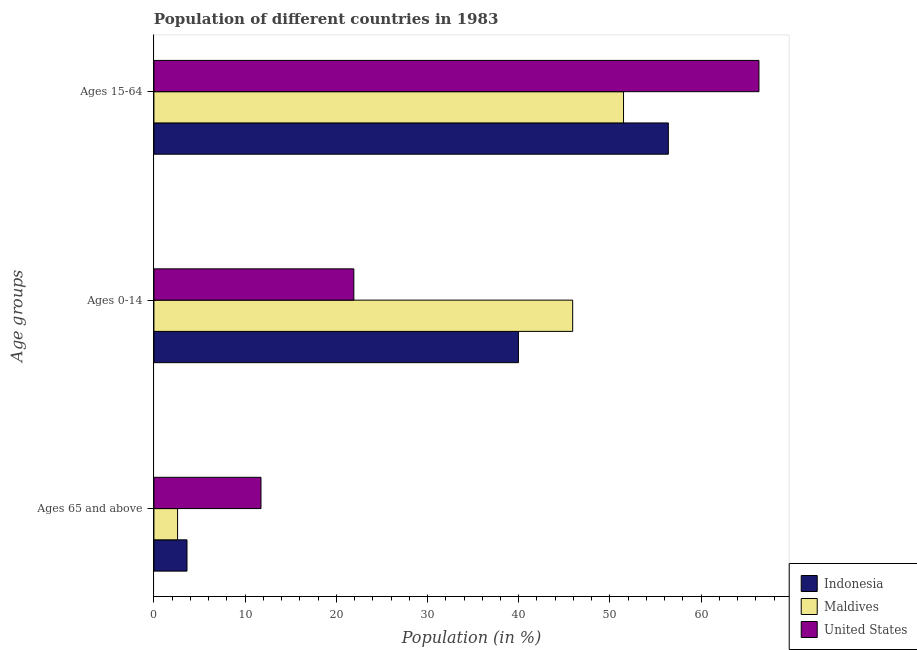How many groups of bars are there?
Offer a terse response. 3. Are the number of bars on each tick of the Y-axis equal?
Offer a terse response. Yes. How many bars are there on the 1st tick from the top?
Ensure brevity in your answer.  3. How many bars are there on the 1st tick from the bottom?
Make the answer very short. 3. What is the label of the 3rd group of bars from the top?
Offer a terse response. Ages 65 and above. What is the percentage of population within the age-group 0-14 in Maldives?
Offer a terse response. 45.92. Across all countries, what is the maximum percentage of population within the age-group 0-14?
Provide a succinct answer. 45.92. Across all countries, what is the minimum percentage of population within the age-group 0-14?
Keep it short and to the point. 21.92. In which country was the percentage of population within the age-group 15-64 minimum?
Make the answer very short. Maldives. What is the total percentage of population within the age-group 15-64 in the graph?
Offer a very short reply. 174.24. What is the difference between the percentage of population within the age-group 0-14 in United States and that in Maldives?
Offer a terse response. -23.99. What is the difference between the percentage of population within the age-group of 65 and above in Maldives and the percentage of population within the age-group 0-14 in Indonesia?
Ensure brevity in your answer.  -37.37. What is the average percentage of population within the age-group 15-64 per country?
Your answer should be compact. 58.08. What is the difference between the percentage of population within the age-group 0-14 and percentage of population within the age-group 15-64 in United States?
Keep it short and to the point. -44.42. In how many countries, is the percentage of population within the age-group of 65 and above greater than 48 %?
Offer a terse response. 0. What is the ratio of the percentage of population within the age-group 0-14 in Maldives to that in United States?
Your answer should be very brief. 2.09. Is the percentage of population within the age-group of 65 and above in Maldives less than that in Indonesia?
Your answer should be compact. Yes. What is the difference between the highest and the second highest percentage of population within the age-group 0-14?
Keep it short and to the point. 5.95. What is the difference between the highest and the lowest percentage of population within the age-group 0-14?
Provide a succinct answer. 23.99. Is the sum of the percentage of population within the age-group 0-14 in Maldives and United States greater than the maximum percentage of population within the age-group of 65 and above across all countries?
Ensure brevity in your answer.  Yes. What does the 1st bar from the bottom in Ages 15-64 represents?
Make the answer very short. Indonesia. How many bars are there?
Make the answer very short. 9. How many countries are there in the graph?
Your answer should be compact. 3. What is the difference between two consecutive major ticks on the X-axis?
Your response must be concise. 10. Are the values on the major ticks of X-axis written in scientific E-notation?
Offer a very short reply. No. Does the graph contain any zero values?
Ensure brevity in your answer.  No. Does the graph contain grids?
Your response must be concise. No. How many legend labels are there?
Your answer should be very brief. 3. What is the title of the graph?
Your response must be concise. Population of different countries in 1983. Does "Maldives" appear as one of the legend labels in the graph?
Make the answer very short. Yes. What is the label or title of the X-axis?
Offer a very short reply. Population (in %). What is the label or title of the Y-axis?
Offer a very short reply. Age groups. What is the Population (in %) in Indonesia in Ages 65 and above?
Keep it short and to the point. 3.63. What is the Population (in %) in Maldives in Ages 65 and above?
Provide a short and direct response. 2.59. What is the Population (in %) of United States in Ages 65 and above?
Offer a very short reply. 11.74. What is the Population (in %) in Indonesia in Ages 0-14?
Ensure brevity in your answer.  39.97. What is the Population (in %) in Maldives in Ages 0-14?
Your response must be concise. 45.92. What is the Population (in %) in United States in Ages 0-14?
Offer a terse response. 21.92. What is the Population (in %) of Indonesia in Ages 15-64?
Give a very brief answer. 56.4. What is the Population (in %) of Maldives in Ages 15-64?
Give a very brief answer. 51.49. What is the Population (in %) in United States in Ages 15-64?
Ensure brevity in your answer.  66.34. Across all Age groups, what is the maximum Population (in %) in Indonesia?
Keep it short and to the point. 56.4. Across all Age groups, what is the maximum Population (in %) in Maldives?
Keep it short and to the point. 51.49. Across all Age groups, what is the maximum Population (in %) in United States?
Provide a short and direct response. 66.34. Across all Age groups, what is the minimum Population (in %) of Indonesia?
Make the answer very short. 3.63. Across all Age groups, what is the minimum Population (in %) of Maldives?
Offer a very short reply. 2.59. Across all Age groups, what is the minimum Population (in %) of United States?
Keep it short and to the point. 11.74. What is the total Population (in %) in Indonesia in the graph?
Make the answer very short. 100. What is the total Population (in %) of United States in the graph?
Your response must be concise. 100. What is the difference between the Population (in %) in Indonesia in Ages 65 and above and that in Ages 0-14?
Make the answer very short. -36.34. What is the difference between the Population (in %) in Maldives in Ages 65 and above and that in Ages 0-14?
Offer a very short reply. -43.32. What is the difference between the Population (in %) in United States in Ages 65 and above and that in Ages 0-14?
Your answer should be compact. -10.18. What is the difference between the Population (in %) of Indonesia in Ages 65 and above and that in Ages 15-64?
Give a very brief answer. -52.78. What is the difference between the Population (in %) of Maldives in Ages 65 and above and that in Ages 15-64?
Make the answer very short. -48.9. What is the difference between the Population (in %) of United States in Ages 65 and above and that in Ages 15-64?
Offer a terse response. -54.6. What is the difference between the Population (in %) of Indonesia in Ages 0-14 and that in Ages 15-64?
Offer a terse response. -16.44. What is the difference between the Population (in %) in Maldives in Ages 0-14 and that in Ages 15-64?
Make the answer very short. -5.58. What is the difference between the Population (in %) of United States in Ages 0-14 and that in Ages 15-64?
Your response must be concise. -44.42. What is the difference between the Population (in %) in Indonesia in Ages 65 and above and the Population (in %) in Maldives in Ages 0-14?
Ensure brevity in your answer.  -42.29. What is the difference between the Population (in %) in Indonesia in Ages 65 and above and the Population (in %) in United States in Ages 0-14?
Your answer should be very brief. -18.29. What is the difference between the Population (in %) in Maldives in Ages 65 and above and the Population (in %) in United States in Ages 0-14?
Your response must be concise. -19.33. What is the difference between the Population (in %) in Indonesia in Ages 65 and above and the Population (in %) in Maldives in Ages 15-64?
Your answer should be compact. -47.86. What is the difference between the Population (in %) in Indonesia in Ages 65 and above and the Population (in %) in United States in Ages 15-64?
Keep it short and to the point. -62.71. What is the difference between the Population (in %) in Maldives in Ages 65 and above and the Population (in %) in United States in Ages 15-64?
Give a very brief answer. -63.75. What is the difference between the Population (in %) of Indonesia in Ages 0-14 and the Population (in %) of Maldives in Ages 15-64?
Provide a succinct answer. -11.52. What is the difference between the Population (in %) in Indonesia in Ages 0-14 and the Population (in %) in United States in Ages 15-64?
Give a very brief answer. -26.37. What is the difference between the Population (in %) of Maldives in Ages 0-14 and the Population (in %) of United States in Ages 15-64?
Provide a short and direct response. -20.43. What is the average Population (in %) in Indonesia per Age groups?
Offer a very short reply. 33.33. What is the average Population (in %) in Maldives per Age groups?
Make the answer very short. 33.33. What is the average Population (in %) of United States per Age groups?
Your answer should be very brief. 33.33. What is the difference between the Population (in %) in Indonesia and Population (in %) in Maldives in Ages 65 and above?
Make the answer very short. 1.03. What is the difference between the Population (in %) in Indonesia and Population (in %) in United States in Ages 65 and above?
Provide a succinct answer. -8.11. What is the difference between the Population (in %) in Maldives and Population (in %) in United States in Ages 65 and above?
Provide a succinct answer. -9.15. What is the difference between the Population (in %) in Indonesia and Population (in %) in Maldives in Ages 0-14?
Your answer should be compact. -5.95. What is the difference between the Population (in %) in Indonesia and Population (in %) in United States in Ages 0-14?
Your answer should be compact. 18.05. What is the difference between the Population (in %) of Maldives and Population (in %) of United States in Ages 0-14?
Provide a short and direct response. 23.99. What is the difference between the Population (in %) of Indonesia and Population (in %) of Maldives in Ages 15-64?
Give a very brief answer. 4.91. What is the difference between the Population (in %) of Indonesia and Population (in %) of United States in Ages 15-64?
Provide a short and direct response. -9.94. What is the difference between the Population (in %) in Maldives and Population (in %) in United States in Ages 15-64?
Provide a short and direct response. -14.85. What is the ratio of the Population (in %) in Indonesia in Ages 65 and above to that in Ages 0-14?
Provide a short and direct response. 0.09. What is the ratio of the Population (in %) of Maldives in Ages 65 and above to that in Ages 0-14?
Offer a terse response. 0.06. What is the ratio of the Population (in %) of United States in Ages 65 and above to that in Ages 0-14?
Your answer should be very brief. 0.54. What is the ratio of the Population (in %) of Indonesia in Ages 65 and above to that in Ages 15-64?
Make the answer very short. 0.06. What is the ratio of the Population (in %) in Maldives in Ages 65 and above to that in Ages 15-64?
Keep it short and to the point. 0.05. What is the ratio of the Population (in %) in United States in Ages 65 and above to that in Ages 15-64?
Give a very brief answer. 0.18. What is the ratio of the Population (in %) in Indonesia in Ages 0-14 to that in Ages 15-64?
Your answer should be very brief. 0.71. What is the ratio of the Population (in %) in Maldives in Ages 0-14 to that in Ages 15-64?
Your answer should be compact. 0.89. What is the ratio of the Population (in %) in United States in Ages 0-14 to that in Ages 15-64?
Your answer should be compact. 0.33. What is the difference between the highest and the second highest Population (in %) in Indonesia?
Your answer should be very brief. 16.44. What is the difference between the highest and the second highest Population (in %) in Maldives?
Give a very brief answer. 5.58. What is the difference between the highest and the second highest Population (in %) of United States?
Your answer should be compact. 44.42. What is the difference between the highest and the lowest Population (in %) of Indonesia?
Ensure brevity in your answer.  52.78. What is the difference between the highest and the lowest Population (in %) of Maldives?
Ensure brevity in your answer.  48.9. What is the difference between the highest and the lowest Population (in %) of United States?
Offer a terse response. 54.6. 